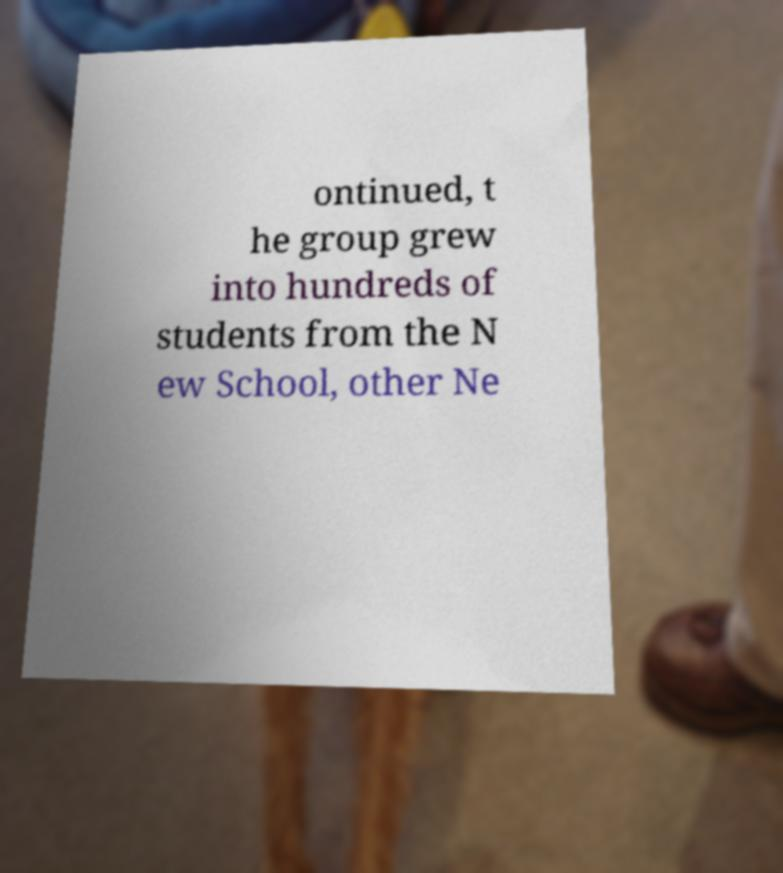Could you extract and type out the text from this image? ontinued, t he group grew into hundreds of students from the N ew School, other Ne 